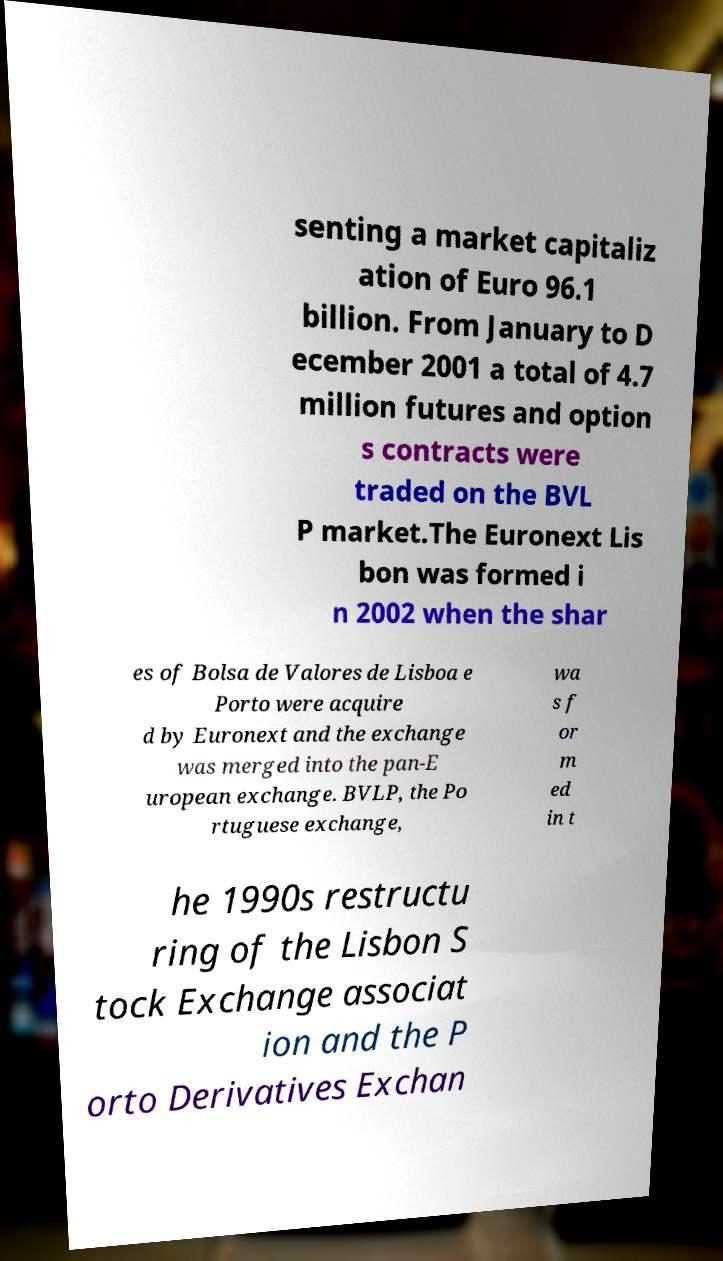I need the written content from this picture converted into text. Can you do that? senting a market capitaliz ation of Euro 96.1 billion. From January to D ecember 2001 a total of 4.7 million futures and option s contracts were traded on the BVL P market.The Euronext Lis bon was formed i n 2002 when the shar es of Bolsa de Valores de Lisboa e Porto were acquire d by Euronext and the exchange was merged into the pan-E uropean exchange. BVLP, the Po rtuguese exchange, wa s f or m ed in t he 1990s restructu ring of the Lisbon S tock Exchange associat ion and the P orto Derivatives Exchan 